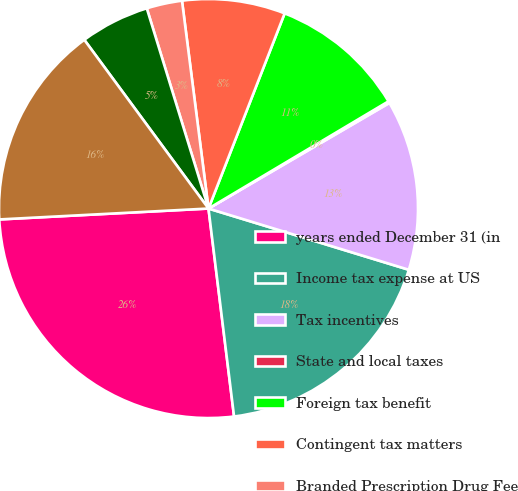Convert chart. <chart><loc_0><loc_0><loc_500><loc_500><pie_chart><fcel>years ended December 31 (in<fcel>Income tax expense at US<fcel>Tax incentives<fcel>State and local taxes<fcel>Foreign tax benefit<fcel>Contingent tax matters<fcel>Branded Prescription Drug Fee<fcel>Other factors<fcel>Income tax expense<nl><fcel>26.12%<fcel>18.33%<fcel>13.13%<fcel>0.14%<fcel>10.53%<fcel>7.94%<fcel>2.74%<fcel>5.34%<fcel>15.73%<nl></chart> 